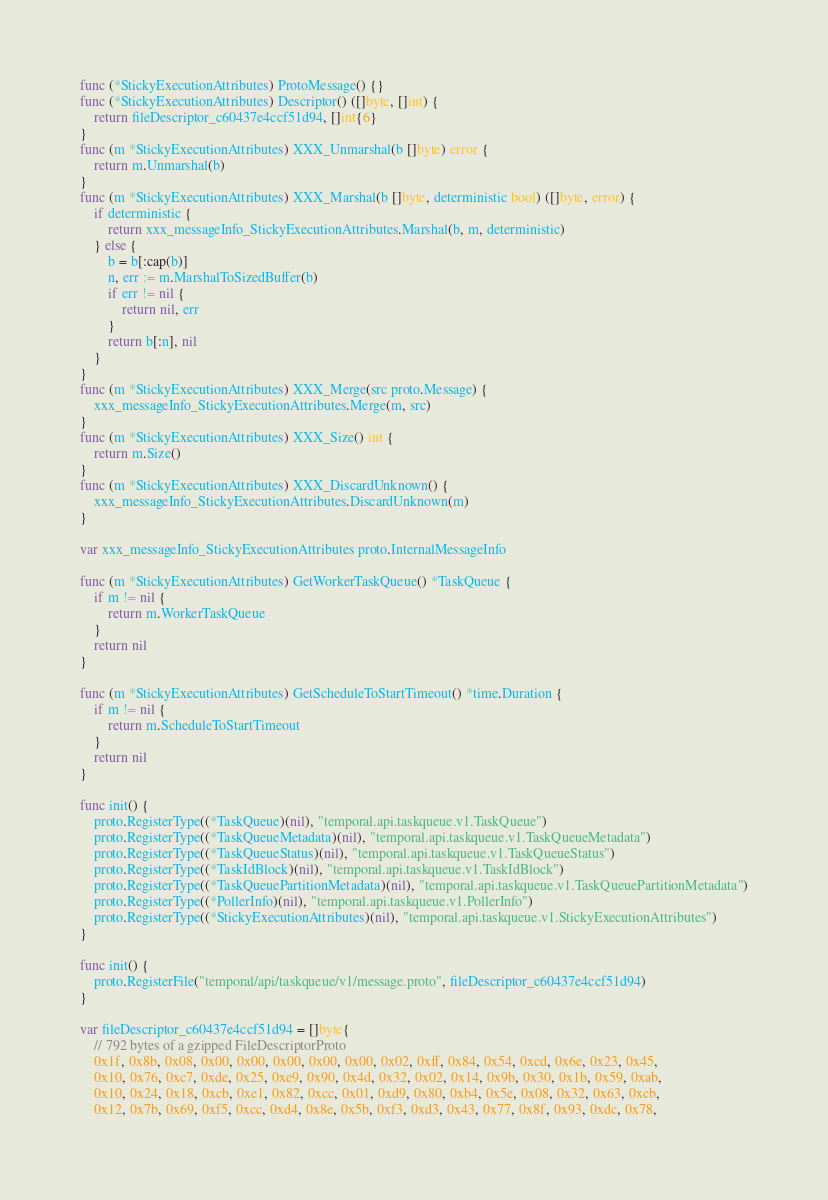<code> <loc_0><loc_0><loc_500><loc_500><_Go_>func (*StickyExecutionAttributes) ProtoMessage() {}
func (*StickyExecutionAttributes) Descriptor() ([]byte, []int) {
	return fileDescriptor_c60437e4ccf51d94, []int{6}
}
func (m *StickyExecutionAttributes) XXX_Unmarshal(b []byte) error {
	return m.Unmarshal(b)
}
func (m *StickyExecutionAttributes) XXX_Marshal(b []byte, deterministic bool) ([]byte, error) {
	if deterministic {
		return xxx_messageInfo_StickyExecutionAttributes.Marshal(b, m, deterministic)
	} else {
		b = b[:cap(b)]
		n, err := m.MarshalToSizedBuffer(b)
		if err != nil {
			return nil, err
		}
		return b[:n], nil
	}
}
func (m *StickyExecutionAttributes) XXX_Merge(src proto.Message) {
	xxx_messageInfo_StickyExecutionAttributes.Merge(m, src)
}
func (m *StickyExecutionAttributes) XXX_Size() int {
	return m.Size()
}
func (m *StickyExecutionAttributes) XXX_DiscardUnknown() {
	xxx_messageInfo_StickyExecutionAttributes.DiscardUnknown(m)
}

var xxx_messageInfo_StickyExecutionAttributes proto.InternalMessageInfo

func (m *StickyExecutionAttributes) GetWorkerTaskQueue() *TaskQueue {
	if m != nil {
		return m.WorkerTaskQueue
	}
	return nil
}

func (m *StickyExecutionAttributes) GetScheduleToStartTimeout() *time.Duration {
	if m != nil {
		return m.ScheduleToStartTimeout
	}
	return nil
}

func init() {
	proto.RegisterType((*TaskQueue)(nil), "temporal.api.taskqueue.v1.TaskQueue")
	proto.RegisterType((*TaskQueueMetadata)(nil), "temporal.api.taskqueue.v1.TaskQueueMetadata")
	proto.RegisterType((*TaskQueueStatus)(nil), "temporal.api.taskqueue.v1.TaskQueueStatus")
	proto.RegisterType((*TaskIdBlock)(nil), "temporal.api.taskqueue.v1.TaskIdBlock")
	proto.RegisterType((*TaskQueuePartitionMetadata)(nil), "temporal.api.taskqueue.v1.TaskQueuePartitionMetadata")
	proto.RegisterType((*PollerInfo)(nil), "temporal.api.taskqueue.v1.PollerInfo")
	proto.RegisterType((*StickyExecutionAttributes)(nil), "temporal.api.taskqueue.v1.StickyExecutionAttributes")
}

func init() {
	proto.RegisterFile("temporal/api/taskqueue/v1/message.proto", fileDescriptor_c60437e4ccf51d94)
}

var fileDescriptor_c60437e4ccf51d94 = []byte{
	// 792 bytes of a gzipped FileDescriptorProto
	0x1f, 0x8b, 0x08, 0x00, 0x00, 0x00, 0x00, 0x00, 0x02, 0xff, 0x84, 0x54, 0xcd, 0x6e, 0x23, 0x45,
	0x10, 0x76, 0xc7, 0xde, 0x25, 0xe9, 0x90, 0x4d, 0x32, 0x02, 0x14, 0x9b, 0x30, 0x1b, 0x59, 0xab,
	0x10, 0x24, 0x18, 0xcb, 0xe1, 0x82, 0xcc, 0x01, 0xd9, 0x80, 0xb4, 0x5e, 0x08, 0x32, 0x63, 0xcb,
	0x12, 0x7b, 0x69, 0xf5, 0xcc, 0xd4, 0x8e, 0x5b, 0xf3, 0xd3, 0x43, 0x77, 0x8f, 0x93, 0xdc, 0x78,</code> 